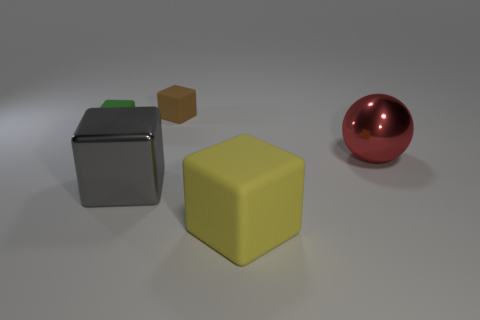What is the shape of the object that is both to the right of the shiny cube and behind the large red metallic ball?
Give a very brief answer. Cube. What number of objects are either brown things or things that are to the left of the red metallic object?
Provide a short and direct response. 4. Is the red thing made of the same material as the big gray thing?
Provide a short and direct response. Yes. How many other things are the same shape as the big matte thing?
Provide a short and direct response. 3. What is the size of the matte object that is both to the right of the gray shiny object and behind the yellow block?
Your answer should be very brief. Small. How many matte objects are small green blocks or small brown blocks?
Ensure brevity in your answer.  2. Does the tiny thing that is to the left of the big metal cube have the same shape as the rubber thing in front of the gray metal block?
Provide a succinct answer. Yes. Are there any balls that have the same material as the small brown cube?
Your answer should be very brief. No. The metal sphere has what color?
Make the answer very short. Red. There is a cube on the left side of the large gray cube; what size is it?
Provide a short and direct response. Small. 